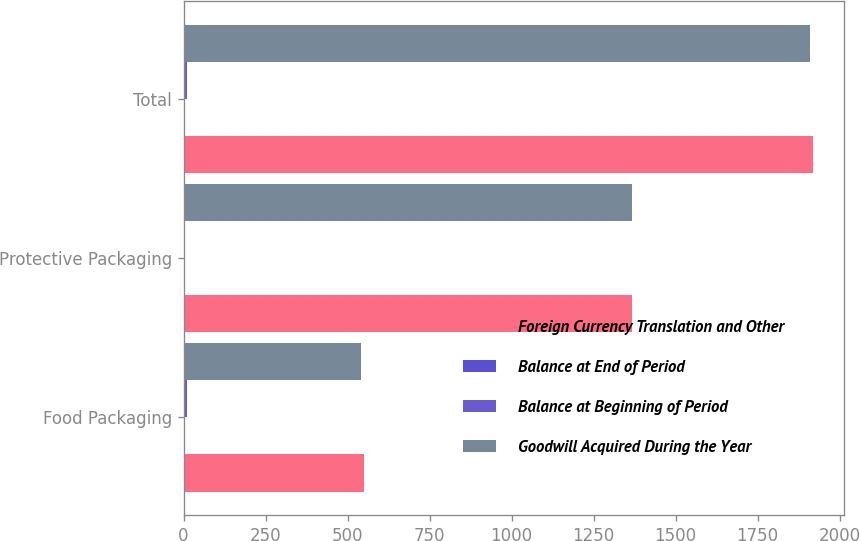<chart> <loc_0><loc_0><loc_500><loc_500><stacked_bar_chart><ecel><fcel>Food Packaging<fcel>Protective Packaging<fcel>Total<nl><fcel>Foreign Currency Translation and Other<fcel>549.8<fcel>1368.2<fcel>1918<nl><fcel>Balance at End of Period<fcel>0.7<fcel>0.8<fcel>1.5<nl><fcel>Balance at Beginning of Period<fcel>10.1<fcel>0.6<fcel>10.7<nl><fcel>Goodwill Acquired During the Year<fcel>540.4<fcel>1368.4<fcel>1908.8<nl></chart> 